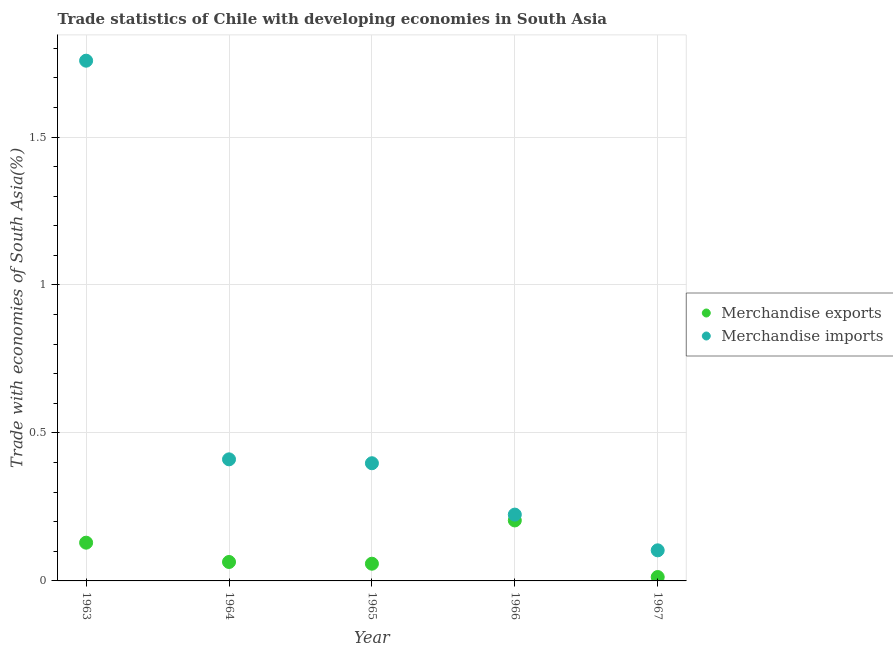How many different coloured dotlines are there?
Provide a short and direct response. 2. What is the merchandise exports in 1965?
Give a very brief answer. 0.06. Across all years, what is the maximum merchandise imports?
Provide a short and direct response. 1.76. Across all years, what is the minimum merchandise exports?
Offer a terse response. 0.01. In which year was the merchandise imports maximum?
Your answer should be very brief. 1963. In which year was the merchandise exports minimum?
Offer a very short reply. 1967. What is the total merchandise imports in the graph?
Your answer should be very brief. 2.89. What is the difference between the merchandise exports in 1963 and that in 1965?
Ensure brevity in your answer.  0.07. What is the difference between the merchandise exports in 1966 and the merchandise imports in 1964?
Your response must be concise. -0.21. What is the average merchandise imports per year?
Make the answer very short. 0.58. In the year 1965, what is the difference between the merchandise imports and merchandise exports?
Keep it short and to the point. 0.34. In how many years, is the merchandise imports greater than 0.1 %?
Ensure brevity in your answer.  5. What is the ratio of the merchandise imports in 1963 to that in 1964?
Offer a terse response. 4.28. Is the merchandise exports in 1964 less than that in 1967?
Give a very brief answer. No. Is the difference between the merchandise imports in 1963 and 1967 greater than the difference between the merchandise exports in 1963 and 1967?
Your response must be concise. Yes. What is the difference between the highest and the second highest merchandise imports?
Provide a short and direct response. 1.35. What is the difference between the highest and the lowest merchandise exports?
Offer a very short reply. 0.19. Does the merchandise exports monotonically increase over the years?
Give a very brief answer. No. How many years are there in the graph?
Make the answer very short. 5. Does the graph contain any zero values?
Give a very brief answer. No. How are the legend labels stacked?
Your response must be concise. Vertical. What is the title of the graph?
Offer a very short reply. Trade statistics of Chile with developing economies in South Asia. Does "Primary" appear as one of the legend labels in the graph?
Ensure brevity in your answer.  No. What is the label or title of the X-axis?
Offer a terse response. Year. What is the label or title of the Y-axis?
Keep it short and to the point. Trade with economies of South Asia(%). What is the Trade with economies of South Asia(%) in Merchandise exports in 1963?
Provide a succinct answer. 0.13. What is the Trade with economies of South Asia(%) of Merchandise imports in 1963?
Offer a very short reply. 1.76. What is the Trade with economies of South Asia(%) in Merchandise exports in 1964?
Provide a short and direct response. 0.06. What is the Trade with economies of South Asia(%) in Merchandise imports in 1964?
Make the answer very short. 0.41. What is the Trade with economies of South Asia(%) of Merchandise exports in 1965?
Make the answer very short. 0.06. What is the Trade with economies of South Asia(%) of Merchandise imports in 1965?
Offer a very short reply. 0.4. What is the Trade with economies of South Asia(%) of Merchandise exports in 1966?
Give a very brief answer. 0.2. What is the Trade with economies of South Asia(%) of Merchandise imports in 1966?
Offer a very short reply. 0.22. What is the Trade with economies of South Asia(%) of Merchandise exports in 1967?
Keep it short and to the point. 0.01. What is the Trade with economies of South Asia(%) in Merchandise imports in 1967?
Keep it short and to the point. 0.1. Across all years, what is the maximum Trade with economies of South Asia(%) in Merchandise exports?
Your answer should be compact. 0.2. Across all years, what is the maximum Trade with economies of South Asia(%) of Merchandise imports?
Provide a succinct answer. 1.76. Across all years, what is the minimum Trade with economies of South Asia(%) of Merchandise exports?
Offer a terse response. 0.01. Across all years, what is the minimum Trade with economies of South Asia(%) in Merchandise imports?
Give a very brief answer. 0.1. What is the total Trade with economies of South Asia(%) in Merchandise exports in the graph?
Offer a very short reply. 0.47. What is the total Trade with economies of South Asia(%) in Merchandise imports in the graph?
Offer a terse response. 2.89. What is the difference between the Trade with economies of South Asia(%) of Merchandise exports in 1963 and that in 1964?
Offer a very short reply. 0.07. What is the difference between the Trade with economies of South Asia(%) of Merchandise imports in 1963 and that in 1964?
Ensure brevity in your answer.  1.35. What is the difference between the Trade with economies of South Asia(%) in Merchandise exports in 1963 and that in 1965?
Provide a succinct answer. 0.07. What is the difference between the Trade with economies of South Asia(%) of Merchandise imports in 1963 and that in 1965?
Make the answer very short. 1.36. What is the difference between the Trade with economies of South Asia(%) in Merchandise exports in 1963 and that in 1966?
Provide a succinct answer. -0.08. What is the difference between the Trade with economies of South Asia(%) of Merchandise imports in 1963 and that in 1966?
Your answer should be very brief. 1.53. What is the difference between the Trade with economies of South Asia(%) in Merchandise exports in 1963 and that in 1967?
Make the answer very short. 0.12. What is the difference between the Trade with economies of South Asia(%) of Merchandise imports in 1963 and that in 1967?
Your answer should be very brief. 1.65. What is the difference between the Trade with economies of South Asia(%) in Merchandise exports in 1964 and that in 1965?
Provide a short and direct response. 0.01. What is the difference between the Trade with economies of South Asia(%) in Merchandise imports in 1964 and that in 1965?
Ensure brevity in your answer.  0.01. What is the difference between the Trade with economies of South Asia(%) in Merchandise exports in 1964 and that in 1966?
Ensure brevity in your answer.  -0.14. What is the difference between the Trade with economies of South Asia(%) of Merchandise imports in 1964 and that in 1966?
Provide a succinct answer. 0.19. What is the difference between the Trade with economies of South Asia(%) in Merchandise exports in 1964 and that in 1967?
Keep it short and to the point. 0.05. What is the difference between the Trade with economies of South Asia(%) of Merchandise imports in 1964 and that in 1967?
Ensure brevity in your answer.  0.31. What is the difference between the Trade with economies of South Asia(%) of Merchandise exports in 1965 and that in 1966?
Make the answer very short. -0.15. What is the difference between the Trade with economies of South Asia(%) in Merchandise imports in 1965 and that in 1966?
Keep it short and to the point. 0.17. What is the difference between the Trade with economies of South Asia(%) in Merchandise exports in 1965 and that in 1967?
Your answer should be compact. 0.04. What is the difference between the Trade with economies of South Asia(%) in Merchandise imports in 1965 and that in 1967?
Provide a succinct answer. 0.29. What is the difference between the Trade with economies of South Asia(%) in Merchandise exports in 1966 and that in 1967?
Provide a succinct answer. 0.19. What is the difference between the Trade with economies of South Asia(%) of Merchandise imports in 1966 and that in 1967?
Keep it short and to the point. 0.12. What is the difference between the Trade with economies of South Asia(%) in Merchandise exports in 1963 and the Trade with economies of South Asia(%) in Merchandise imports in 1964?
Offer a very short reply. -0.28. What is the difference between the Trade with economies of South Asia(%) in Merchandise exports in 1963 and the Trade with economies of South Asia(%) in Merchandise imports in 1965?
Your answer should be very brief. -0.27. What is the difference between the Trade with economies of South Asia(%) of Merchandise exports in 1963 and the Trade with economies of South Asia(%) of Merchandise imports in 1966?
Your response must be concise. -0.09. What is the difference between the Trade with economies of South Asia(%) of Merchandise exports in 1963 and the Trade with economies of South Asia(%) of Merchandise imports in 1967?
Ensure brevity in your answer.  0.03. What is the difference between the Trade with economies of South Asia(%) in Merchandise exports in 1964 and the Trade with economies of South Asia(%) in Merchandise imports in 1965?
Your answer should be very brief. -0.33. What is the difference between the Trade with economies of South Asia(%) in Merchandise exports in 1964 and the Trade with economies of South Asia(%) in Merchandise imports in 1966?
Provide a succinct answer. -0.16. What is the difference between the Trade with economies of South Asia(%) in Merchandise exports in 1964 and the Trade with economies of South Asia(%) in Merchandise imports in 1967?
Offer a terse response. -0.04. What is the difference between the Trade with economies of South Asia(%) in Merchandise exports in 1965 and the Trade with economies of South Asia(%) in Merchandise imports in 1966?
Your response must be concise. -0.17. What is the difference between the Trade with economies of South Asia(%) of Merchandise exports in 1965 and the Trade with economies of South Asia(%) of Merchandise imports in 1967?
Ensure brevity in your answer.  -0.05. What is the difference between the Trade with economies of South Asia(%) of Merchandise exports in 1966 and the Trade with economies of South Asia(%) of Merchandise imports in 1967?
Provide a short and direct response. 0.1. What is the average Trade with economies of South Asia(%) in Merchandise exports per year?
Offer a very short reply. 0.09. What is the average Trade with economies of South Asia(%) in Merchandise imports per year?
Provide a short and direct response. 0.58. In the year 1963, what is the difference between the Trade with economies of South Asia(%) in Merchandise exports and Trade with economies of South Asia(%) in Merchandise imports?
Offer a terse response. -1.63. In the year 1964, what is the difference between the Trade with economies of South Asia(%) in Merchandise exports and Trade with economies of South Asia(%) in Merchandise imports?
Offer a very short reply. -0.35. In the year 1965, what is the difference between the Trade with economies of South Asia(%) of Merchandise exports and Trade with economies of South Asia(%) of Merchandise imports?
Keep it short and to the point. -0.34. In the year 1966, what is the difference between the Trade with economies of South Asia(%) in Merchandise exports and Trade with economies of South Asia(%) in Merchandise imports?
Your response must be concise. -0.02. In the year 1967, what is the difference between the Trade with economies of South Asia(%) of Merchandise exports and Trade with economies of South Asia(%) of Merchandise imports?
Ensure brevity in your answer.  -0.09. What is the ratio of the Trade with economies of South Asia(%) of Merchandise exports in 1963 to that in 1964?
Your answer should be very brief. 2.02. What is the ratio of the Trade with economies of South Asia(%) of Merchandise imports in 1963 to that in 1964?
Offer a terse response. 4.28. What is the ratio of the Trade with economies of South Asia(%) of Merchandise exports in 1963 to that in 1965?
Provide a succinct answer. 2.22. What is the ratio of the Trade with economies of South Asia(%) in Merchandise imports in 1963 to that in 1965?
Your answer should be compact. 4.42. What is the ratio of the Trade with economies of South Asia(%) in Merchandise exports in 1963 to that in 1966?
Your answer should be compact. 0.63. What is the ratio of the Trade with economies of South Asia(%) of Merchandise imports in 1963 to that in 1966?
Keep it short and to the point. 7.84. What is the ratio of the Trade with economies of South Asia(%) in Merchandise exports in 1963 to that in 1967?
Make the answer very short. 9.84. What is the ratio of the Trade with economies of South Asia(%) in Merchandise imports in 1963 to that in 1967?
Your response must be concise. 17.01. What is the ratio of the Trade with economies of South Asia(%) in Merchandise exports in 1964 to that in 1965?
Provide a succinct answer. 1.1. What is the ratio of the Trade with economies of South Asia(%) of Merchandise imports in 1964 to that in 1965?
Your answer should be very brief. 1.03. What is the ratio of the Trade with economies of South Asia(%) of Merchandise exports in 1964 to that in 1966?
Give a very brief answer. 0.31. What is the ratio of the Trade with economies of South Asia(%) in Merchandise imports in 1964 to that in 1966?
Provide a succinct answer. 1.83. What is the ratio of the Trade with economies of South Asia(%) in Merchandise exports in 1964 to that in 1967?
Offer a very short reply. 4.87. What is the ratio of the Trade with economies of South Asia(%) in Merchandise imports in 1964 to that in 1967?
Your answer should be compact. 3.97. What is the ratio of the Trade with economies of South Asia(%) of Merchandise exports in 1965 to that in 1966?
Keep it short and to the point. 0.28. What is the ratio of the Trade with economies of South Asia(%) in Merchandise imports in 1965 to that in 1966?
Give a very brief answer. 1.77. What is the ratio of the Trade with economies of South Asia(%) of Merchandise exports in 1965 to that in 1967?
Make the answer very short. 4.43. What is the ratio of the Trade with economies of South Asia(%) in Merchandise imports in 1965 to that in 1967?
Ensure brevity in your answer.  3.85. What is the ratio of the Trade with economies of South Asia(%) of Merchandise exports in 1966 to that in 1967?
Your answer should be very brief. 15.56. What is the ratio of the Trade with economies of South Asia(%) in Merchandise imports in 1966 to that in 1967?
Your answer should be very brief. 2.17. What is the difference between the highest and the second highest Trade with economies of South Asia(%) of Merchandise exports?
Your response must be concise. 0.08. What is the difference between the highest and the second highest Trade with economies of South Asia(%) in Merchandise imports?
Provide a succinct answer. 1.35. What is the difference between the highest and the lowest Trade with economies of South Asia(%) of Merchandise exports?
Your response must be concise. 0.19. What is the difference between the highest and the lowest Trade with economies of South Asia(%) in Merchandise imports?
Give a very brief answer. 1.65. 